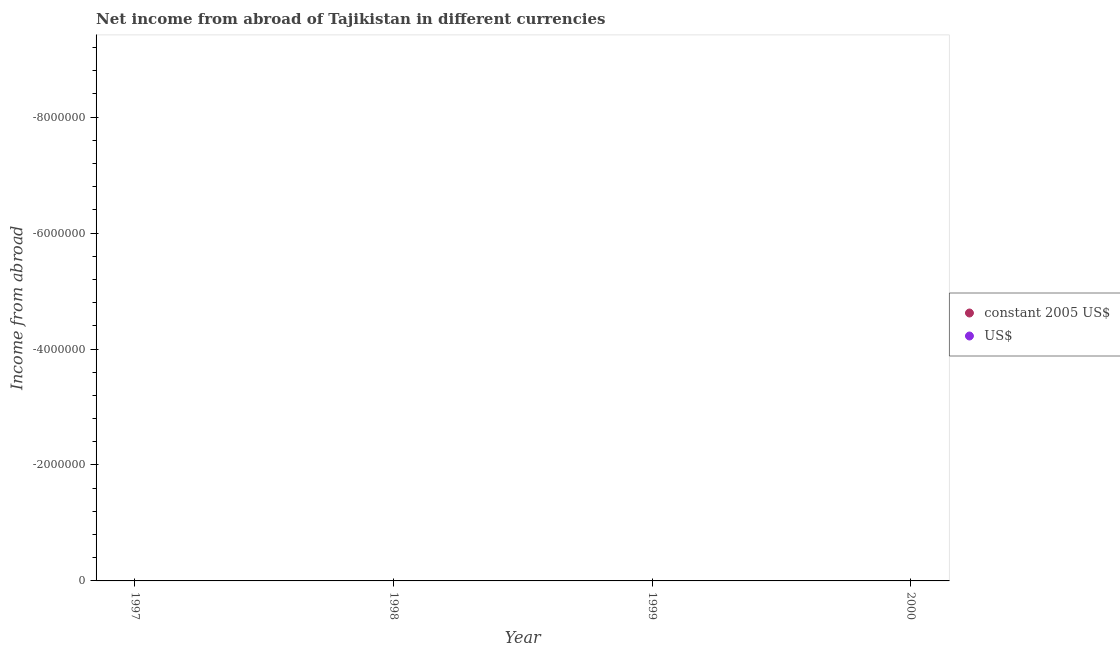How many different coloured dotlines are there?
Provide a short and direct response. 0. What is the difference between the income from abroad in us$ in 1997 and the income from abroad in constant 2005 us$ in 1998?
Your response must be concise. 0. What is the average income from abroad in constant 2005 us$ per year?
Your answer should be very brief. 0. In how many years, is the income from abroad in constant 2005 us$ greater than the average income from abroad in constant 2005 us$ taken over all years?
Offer a very short reply. 0. Does the income from abroad in constant 2005 us$ monotonically increase over the years?
Provide a short and direct response. No. Does the graph contain any zero values?
Your answer should be compact. Yes. Does the graph contain grids?
Give a very brief answer. No. How are the legend labels stacked?
Your response must be concise. Vertical. What is the title of the graph?
Make the answer very short. Net income from abroad of Tajikistan in different currencies. What is the label or title of the Y-axis?
Provide a short and direct response. Income from abroad. What is the Income from abroad of constant 2005 US$ in 1997?
Your response must be concise. 0. What is the Income from abroad of constant 2005 US$ in 1998?
Offer a terse response. 0. What is the Income from abroad in constant 2005 US$ in 1999?
Offer a very short reply. 0. What is the Income from abroad in constant 2005 US$ in 2000?
Your answer should be compact. 0. What is the Income from abroad of US$ in 2000?
Offer a very short reply. 0. What is the total Income from abroad of constant 2005 US$ in the graph?
Give a very brief answer. 0. What is the total Income from abroad of US$ in the graph?
Make the answer very short. 0. What is the average Income from abroad of constant 2005 US$ per year?
Your answer should be compact. 0. 